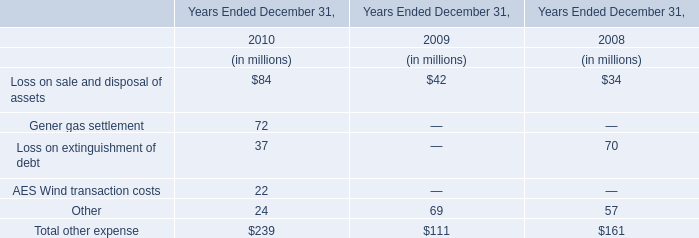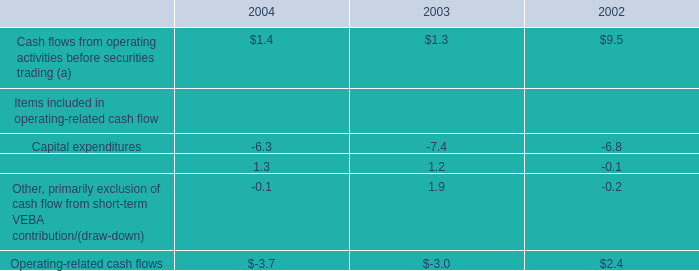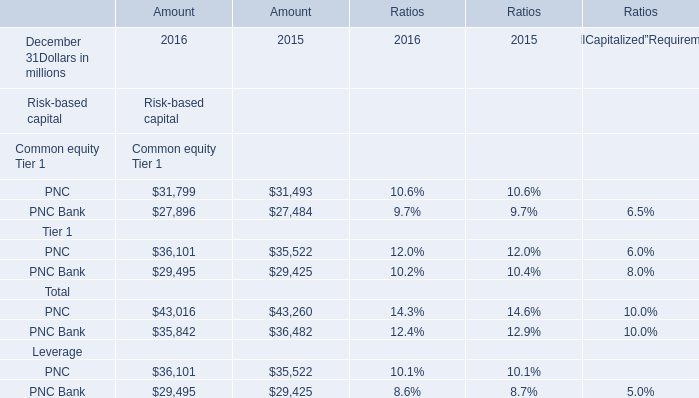If the Amount for Risk-based capital Tier 1: PNC on December 31 develops with the same growth rate in 2016, what will it reach in 2017? (in million) 
Computations: (36101 * (1 + ((36101 - 35522) / 35522)))
Answer: 36689.43756. 